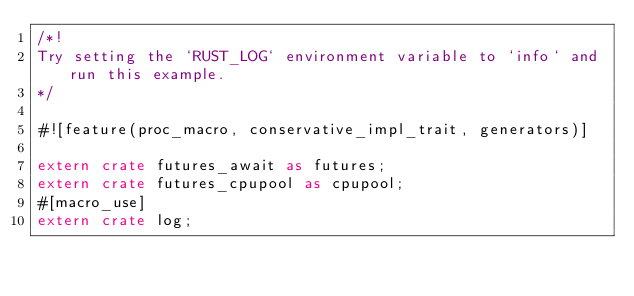<code> <loc_0><loc_0><loc_500><loc_500><_Rust_>/*!
Try setting the `RUST_LOG` environment variable to `info` and run this example.
*/

#![feature(proc_macro, conservative_impl_trait, generators)]

extern crate futures_await as futures;
extern crate futures_cpupool as cpupool;
#[macro_use]
extern crate log;</code> 